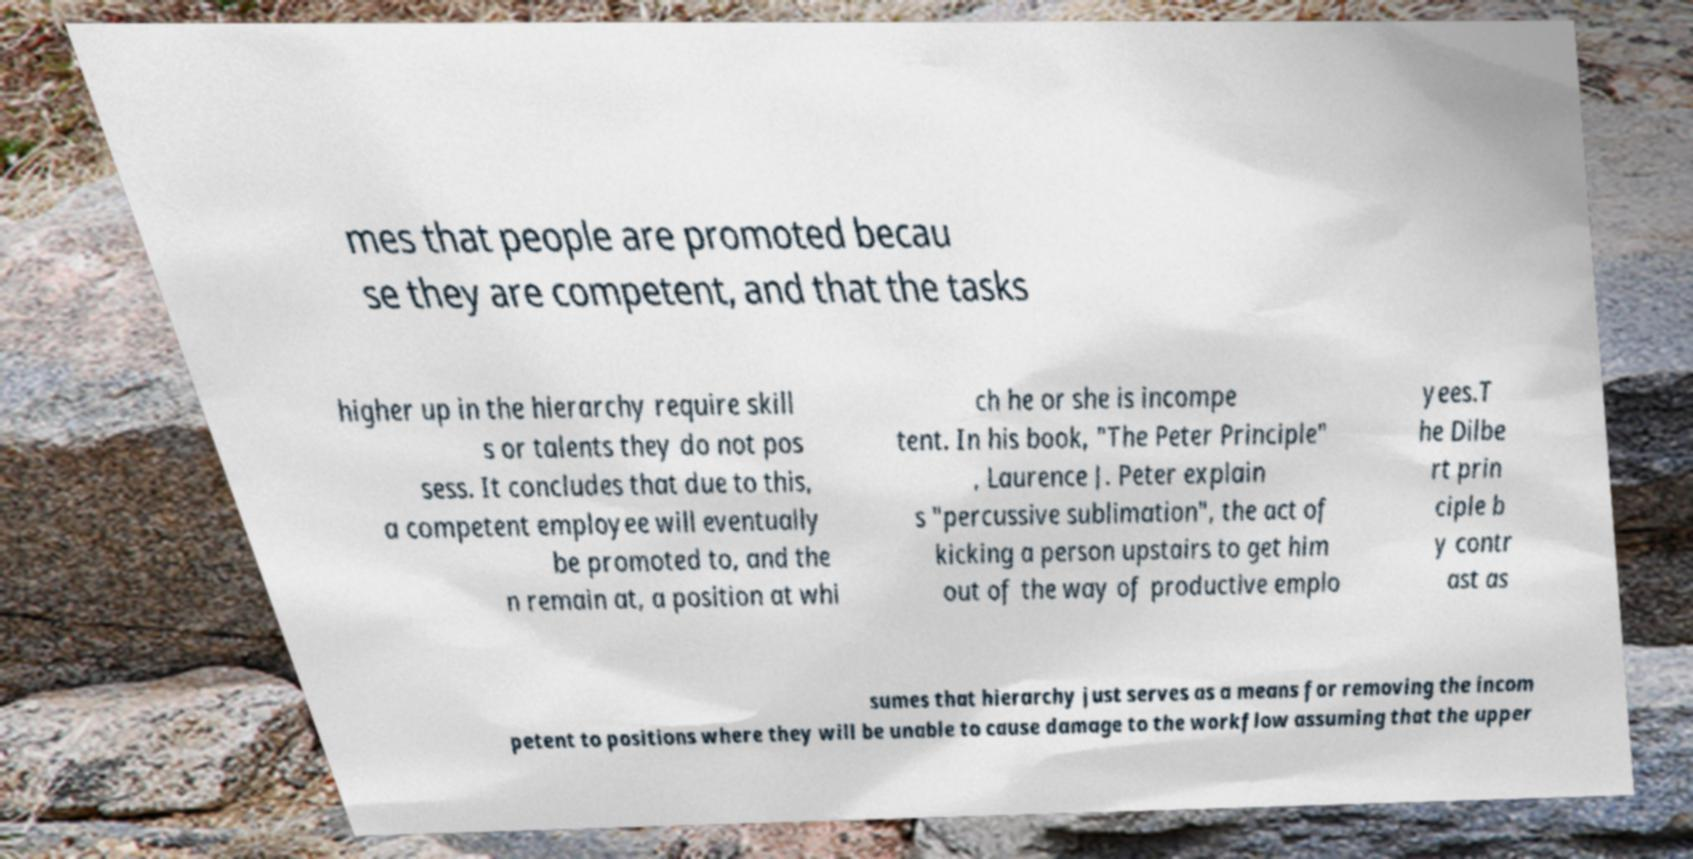What messages or text are displayed in this image? I need them in a readable, typed format. mes that people are promoted becau se they are competent, and that the tasks higher up in the hierarchy require skill s or talents they do not pos sess. It concludes that due to this, a competent employee will eventually be promoted to, and the n remain at, a position at whi ch he or she is incompe tent. In his book, "The Peter Principle" , Laurence J. Peter explain s "percussive sublimation", the act of kicking a person upstairs to get him out of the way of productive emplo yees.T he Dilbe rt prin ciple b y contr ast as sumes that hierarchy just serves as a means for removing the incom petent to positions where they will be unable to cause damage to the workflow assuming that the upper 